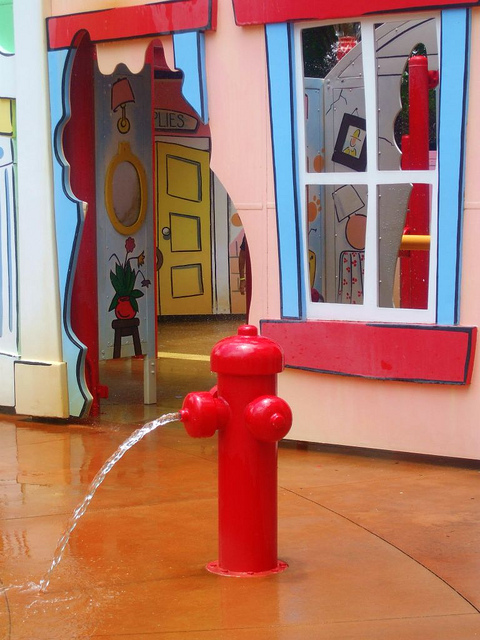Read all the text in this image. LIES 